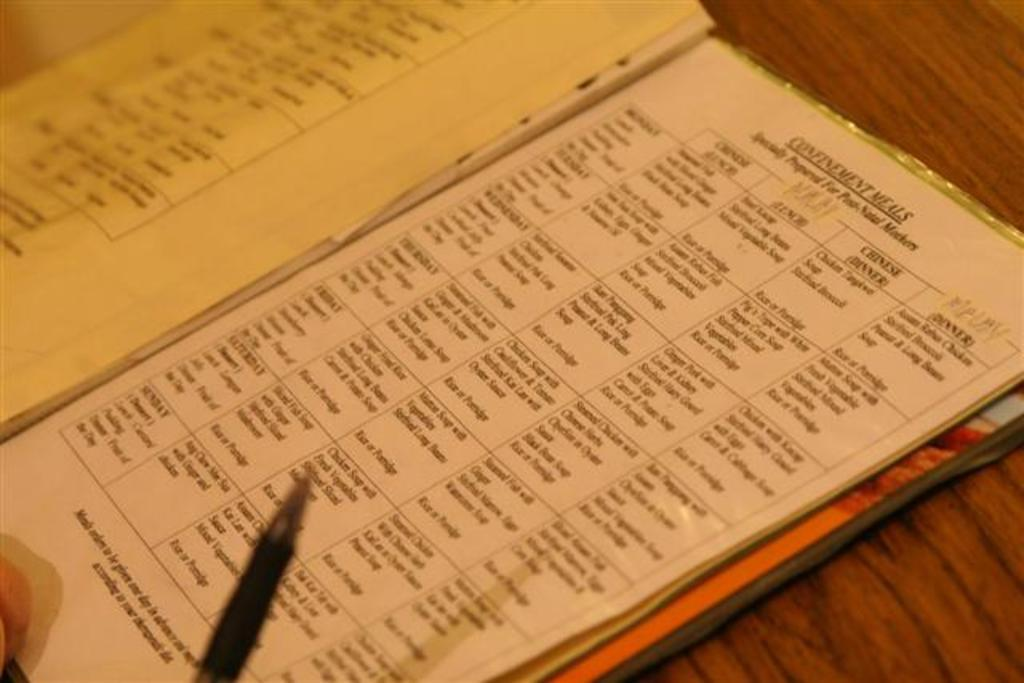What object is placed on the table in the image? There is a book on the table in the image. What writing instrument can be seen in the image? There is a pen in the image. Can you describe a body part visible in the image? A human hand is visible in the image. What type of dress is the moon wearing in the image? There is no moon present in the image, and therefore no dress or any other clothing can be observed. 